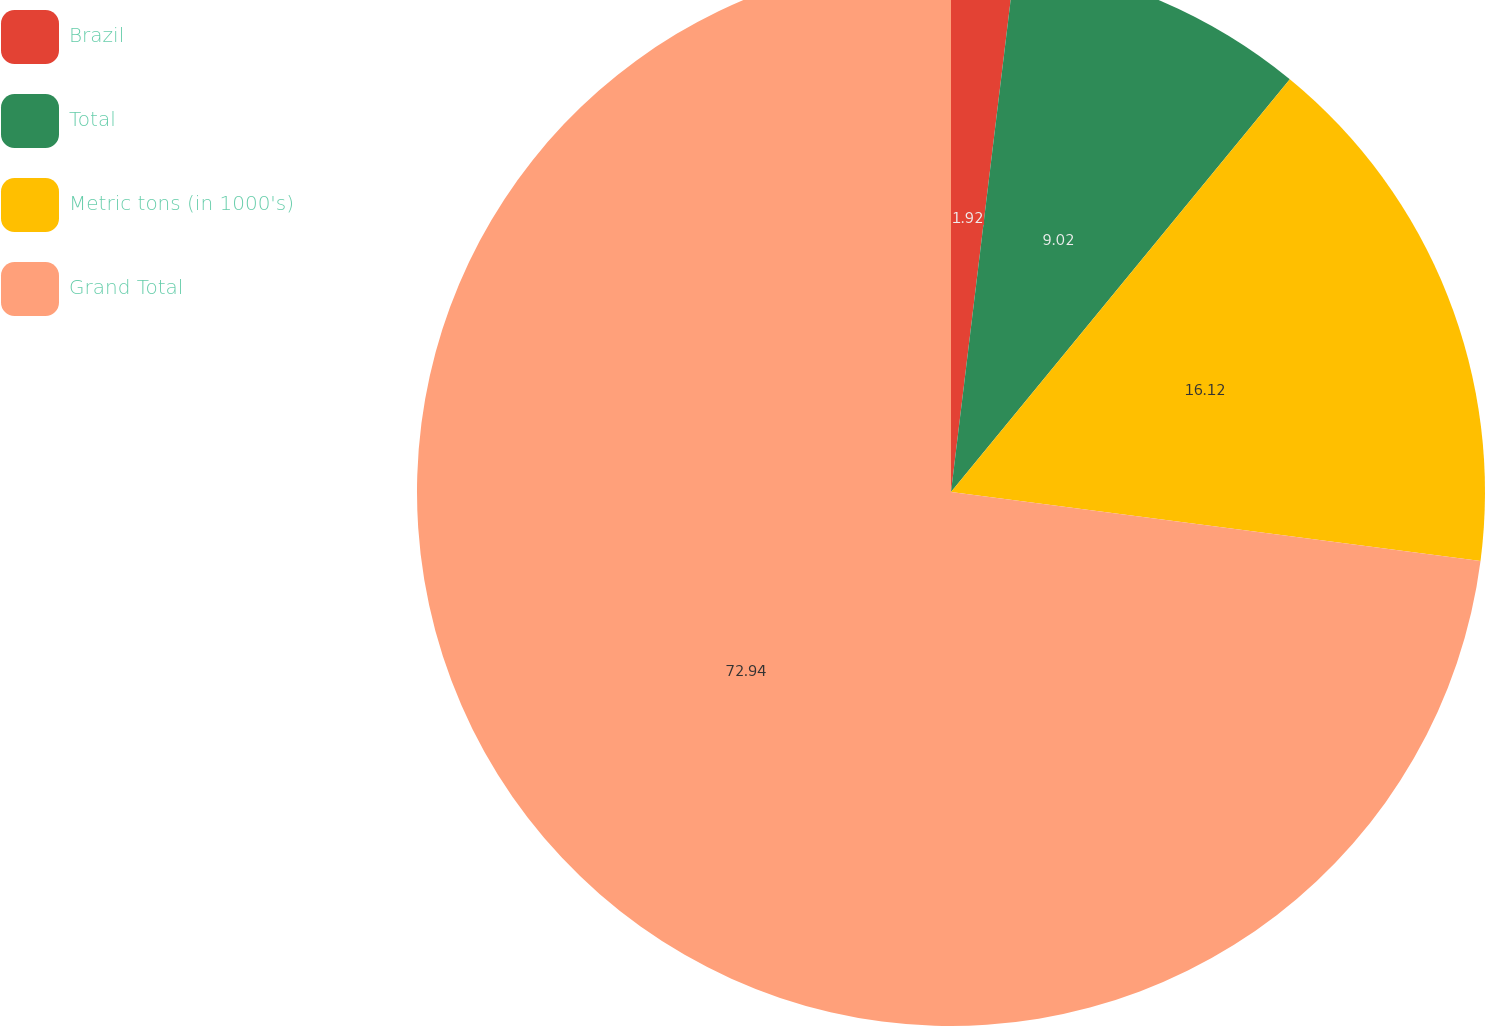Convert chart. <chart><loc_0><loc_0><loc_500><loc_500><pie_chart><fcel>Brazil<fcel>Total<fcel>Metric tons (in 1000's)<fcel>Grand Total<nl><fcel>1.92%<fcel>9.02%<fcel>16.12%<fcel>72.94%<nl></chart> 